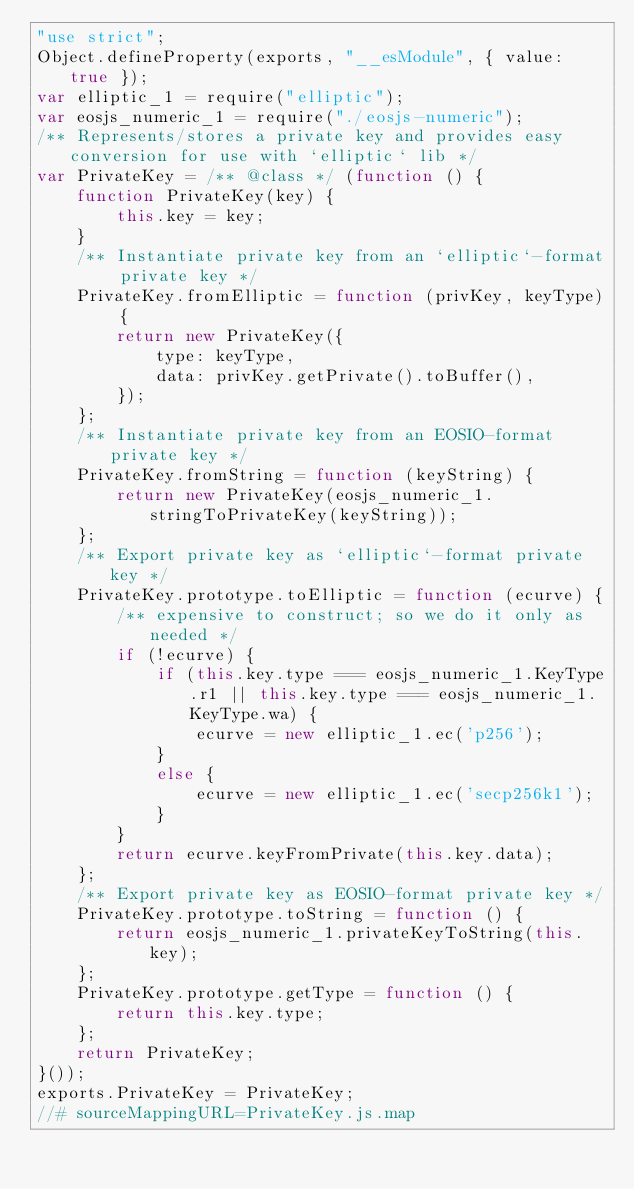<code> <loc_0><loc_0><loc_500><loc_500><_JavaScript_>"use strict";
Object.defineProperty(exports, "__esModule", { value: true });
var elliptic_1 = require("elliptic");
var eosjs_numeric_1 = require("./eosjs-numeric");
/** Represents/stores a private key and provides easy conversion for use with `elliptic` lib */
var PrivateKey = /** @class */ (function () {
    function PrivateKey(key) {
        this.key = key;
    }
    /** Instantiate private key from an `elliptic`-format private key */
    PrivateKey.fromElliptic = function (privKey, keyType) {
        return new PrivateKey({
            type: keyType,
            data: privKey.getPrivate().toBuffer(),
        });
    };
    /** Instantiate private key from an EOSIO-format private key */
    PrivateKey.fromString = function (keyString) {
        return new PrivateKey(eosjs_numeric_1.stringToPrivateKey(keyString));
    };
    /** Export private key as `elliptic`-format private key */
    PrivateKey.prototype.toElliptic = function (ecurve) {
        /** expensive to construct; so we do it only as needed */
        if (!ecurve) {
            if (this.key.type === eosjs_numeric_1.KeyType.r1 || this.key.type === eosjs_numeric_1.KeyType.wa) {
                ecurve = new elliptic_1.ec('p256');
            }
            else {
                ecurve = new elliptic_1.ec('secp256k1');
            }
        }
        return ecurve.keyFromPrivate(this.key.data);
    };
    /** Export private key as EOSIO-format private key */
    PrivateKey.prototype.toString = function () {
        return eosjs_numeric_1.privateKeyToString(this.key);
    };
    PrivateKey.prototype.getType = function () {
        return this.key.type;
    };
    return PrivateKey;
}());
exports.PrivateKey = PrivateKey;
//# sourceMappingURL=PrivateKey.js.map</code> 